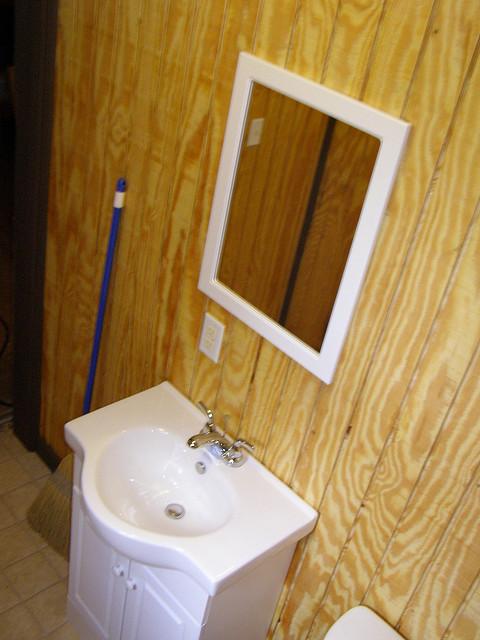What is above the sink?
Short answer required. Mirror. Where might the tissue be?
Write a very short answer. On top of toilet. What is to the left of the sink?
Concise answer only. Broom. 